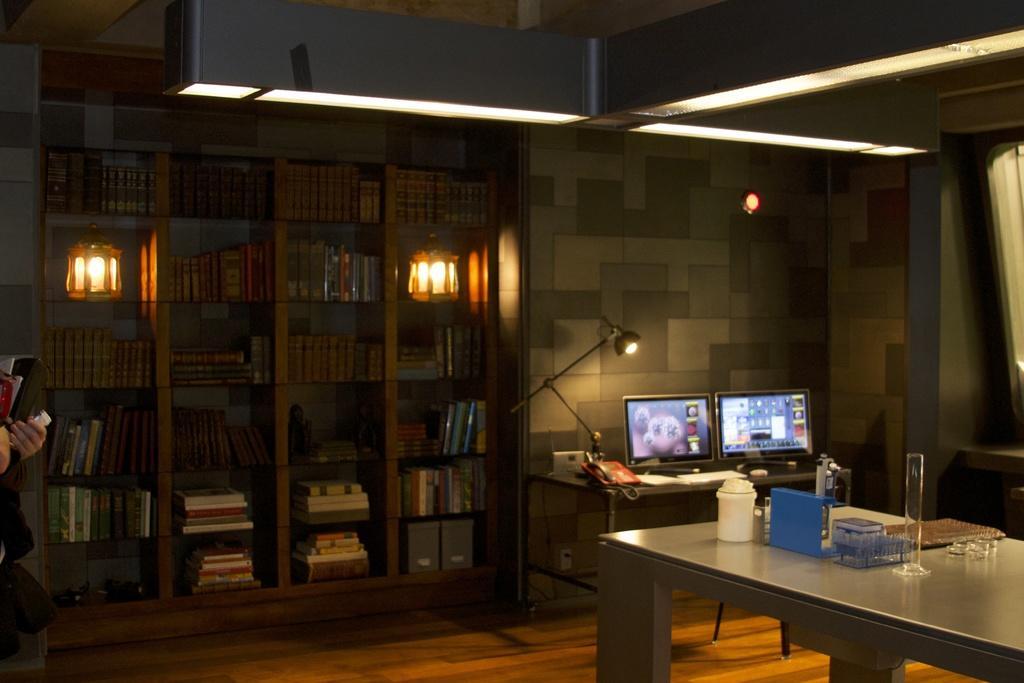Could you give a brief overview of what you see in this image? This image is taken in a room. In this image we can see the books placed in the racks. We can also see the lamp's, lights and also two monitor screens on the table. Image also consists of a phone, bottle, book on the table. At the top we can see the ceiling lights and at the bottom there is floor. On the left there is some person holding the books. 